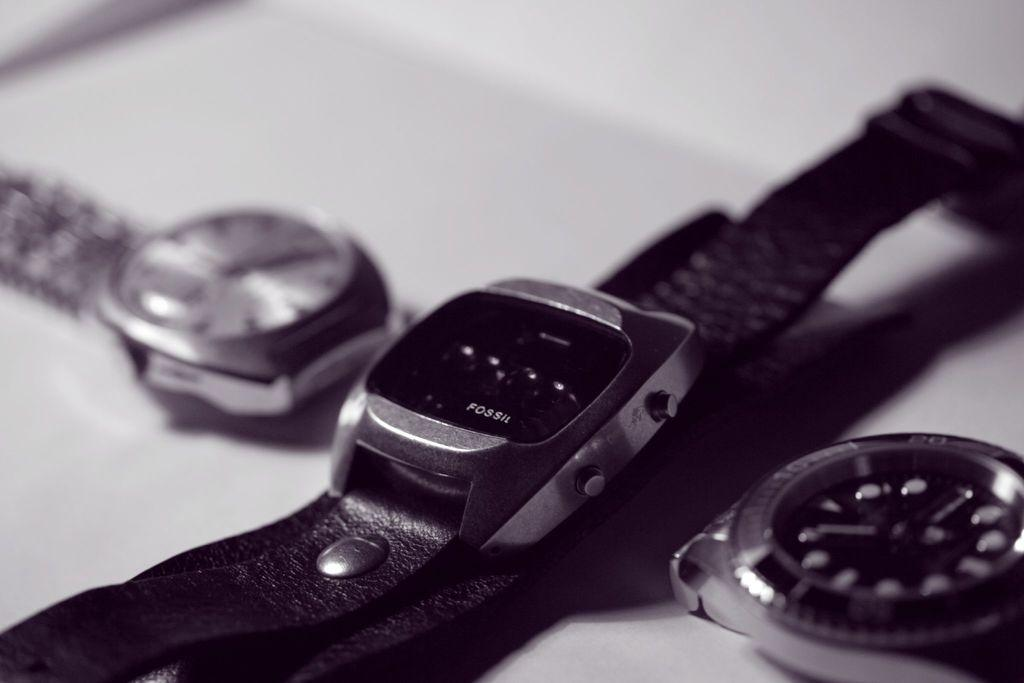<image>
Provide a brief description of the given image. Fossil square metallic women's watch with leather straps and two operating buttons on side. 